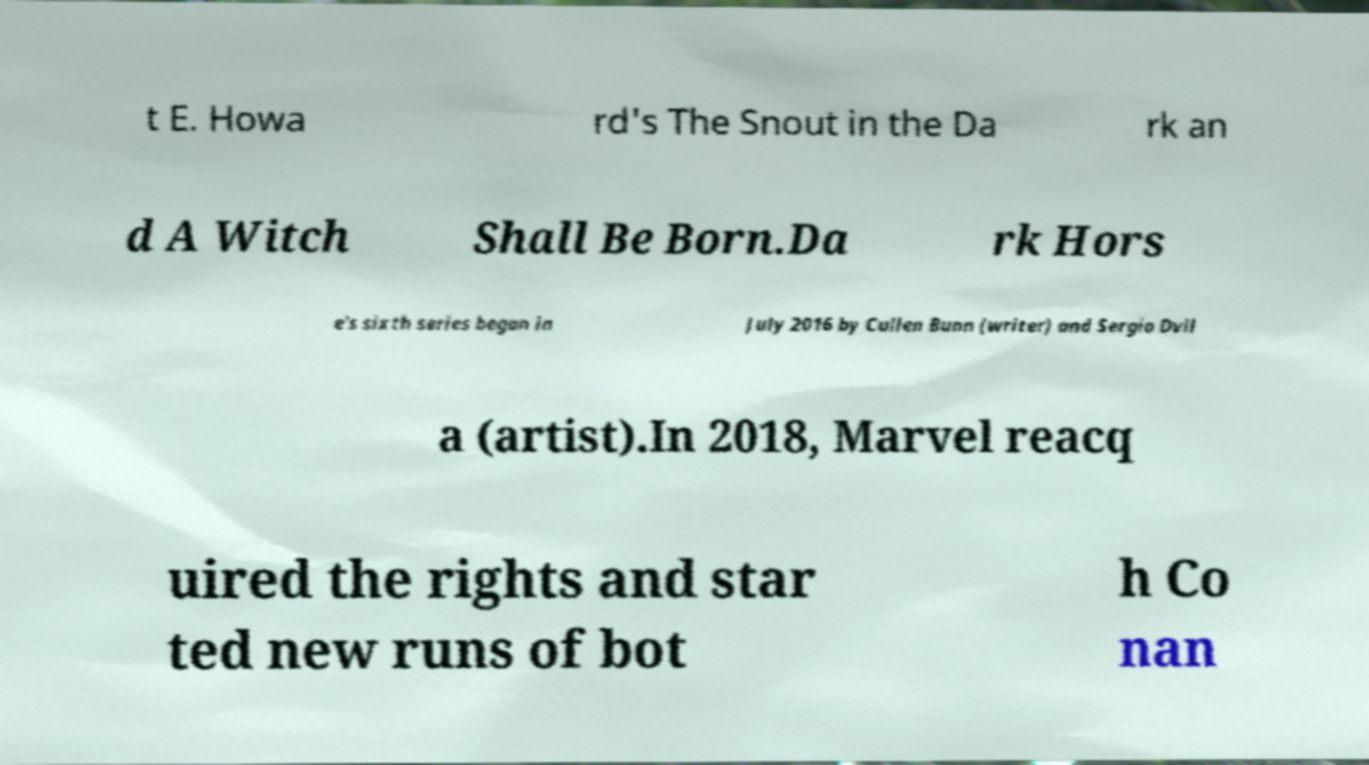Please read and relay the text visible in this image. What does it say? t E. Howa rd's The Snout in the Da rk an d A Witch Shall Be Born.Da rk Hors e's sixth series began in July 2016 by Cullen Bunn (writer) and Sergio Dvil a (artist).In 2018, Marvel reacq uired the rights and star ted new runs of bot h Co nan 